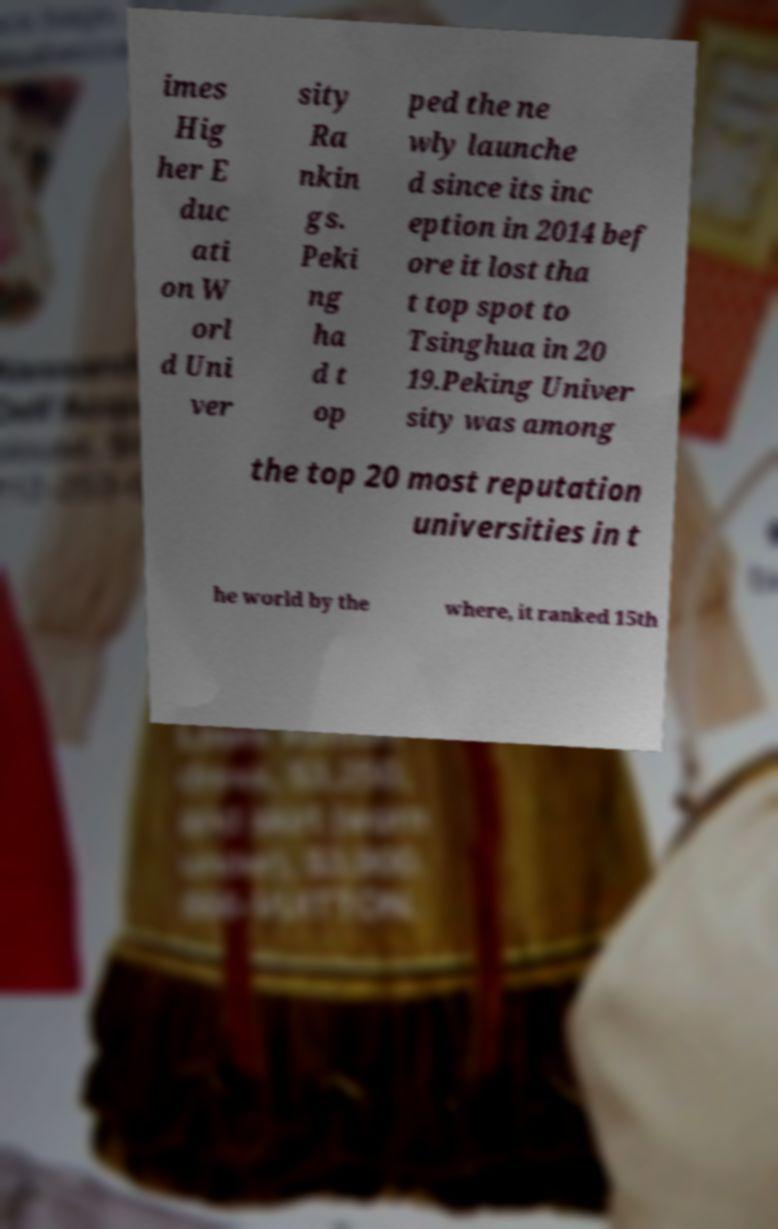Please read and relay the text visible in this image. What does it say? imes Hig her E duc ati on W orl d Uni ver sity Ra nkin gs. Peki ng ha d t op ped the ne wly launche d since its inc eption in 2014 bef ore it lost tha t top spot to Tsinghua in 20 19.Peking Univer sity was among the top 20 most reputation universities in t he world by the where, it ranked 15th 